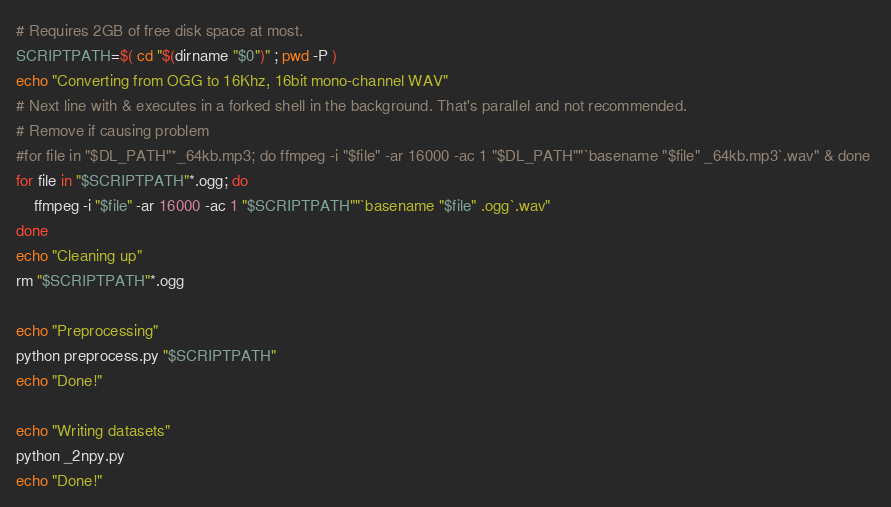<code> <loc_0><loc_0><loc_500><loc_500><_Bash_># Requires 2GB of free disk space at most.
SCRIPTPATH=$( cd "$(dirname "$0")" ; pwd -P )
echo "Converting from OGG to 16Khz, 16bit mono-channel WAV"
# Next line with & executes in a forked shell in the background. That's parallel and not recommended.
# Remove if causing problem
#for file in "$DL_PATH"*_64kb.mp3; do ffmpeg -i "$file" -ar 16000 -ac 1 "$DL_PATH""`basename "$file" _64kb.mp3`.wav" & done 
for file in "$SCRIPTPATH"*.ogg; do
	ffmpeg -i "$file" -ar 16000 -ac 1 "$SCRIPTPATH""`basename "$file" .ogg`.wav"
done 
echo "Cleaning up"
rm "$SCRIPTPATH"*.ogg

echo "Preprocessing"
python preprocess.py "$SCRIPTPATH"
echo "Done!"

echo "Writing datasets"
python _2npy.py
echo "Done!"
</code> 